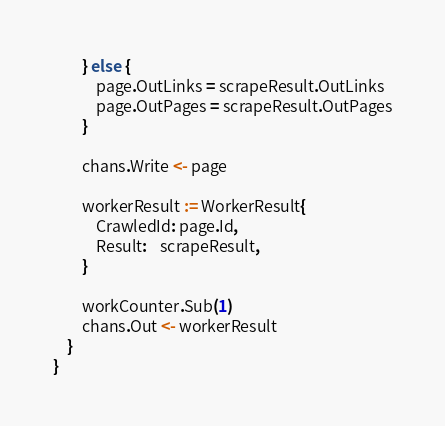<code> <loc_0><loc_0><loc_500><loc_500><_Go_>		} else {
			page.OutLinks = scrapeResult.OutLinks
			page.OutPages = scrapeResult.OutPages
		}

		chans.Write <- page

		workerResult := WorkerResult{
			CrawledId: page.Id,
			Result:    scrapeResult,
		}

		workCounter.Sub(1)
		chans.Out <- workerResult
	}
}
</code> 